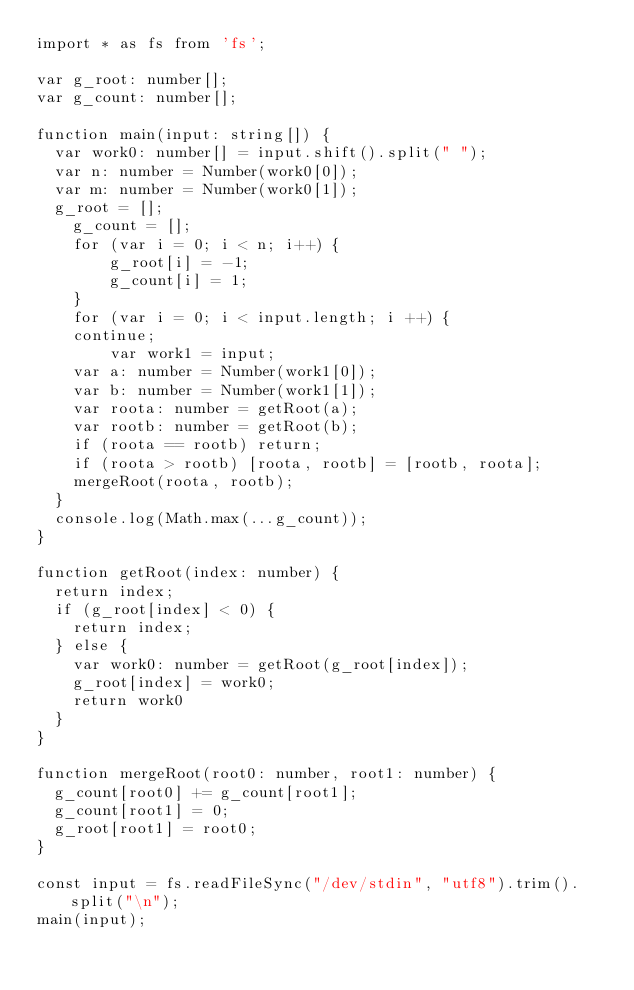Convert code to text. <code><loc_0><loc_0><loc_500><loc_500><_TypeScript_>import * as fs from 'fs';

var g_root: number[];
var g_count: number[];

function main(input: string[]) {
	var work0: number[] = input.shift().split(" ");
	var n: number = Number(work0[0]);
	var m: number = Number(work0[1]);
	g_root = [];
  	g_count = [];
    for (var i = 0; i < n; i++) {
        g_root[i] = -1;
        g_count[i] = 1;
    }
  	for (var i = 0; i < input.length; i ++) {
		continue;
      	var work1 = input;
		var a: number = Number(work1[0]);
		var b: number = Number(work1[1]);
		var roota: number = getRoot(a);
		var rootb: number = getRoot(b);
		if (roota == rootb) return;
		if (roota > rootb) [roota, rootb] = [rootb, roota];
		mergeRoot(roota, rootb);
	}
	console.log(Math.max(...g_count));
}

function getRoot(index: number) {
  return index;
	if (g_root[index] < 0) {
		return index;
	} else {
		var work0: number = getRoot(g_root[index]);
		g_root[index] = work0;
		return work0
	}
}

function mergeRoot(root0: number, root1: number) {
	g_count[root0] += g_count[root1];
	g_count[root1] = 0;
	g_root[root1] = root0;
}

const input = fs.readFileSync("/dev/stdin", "utf8").trim().split("\n");
main(input);
</code> 